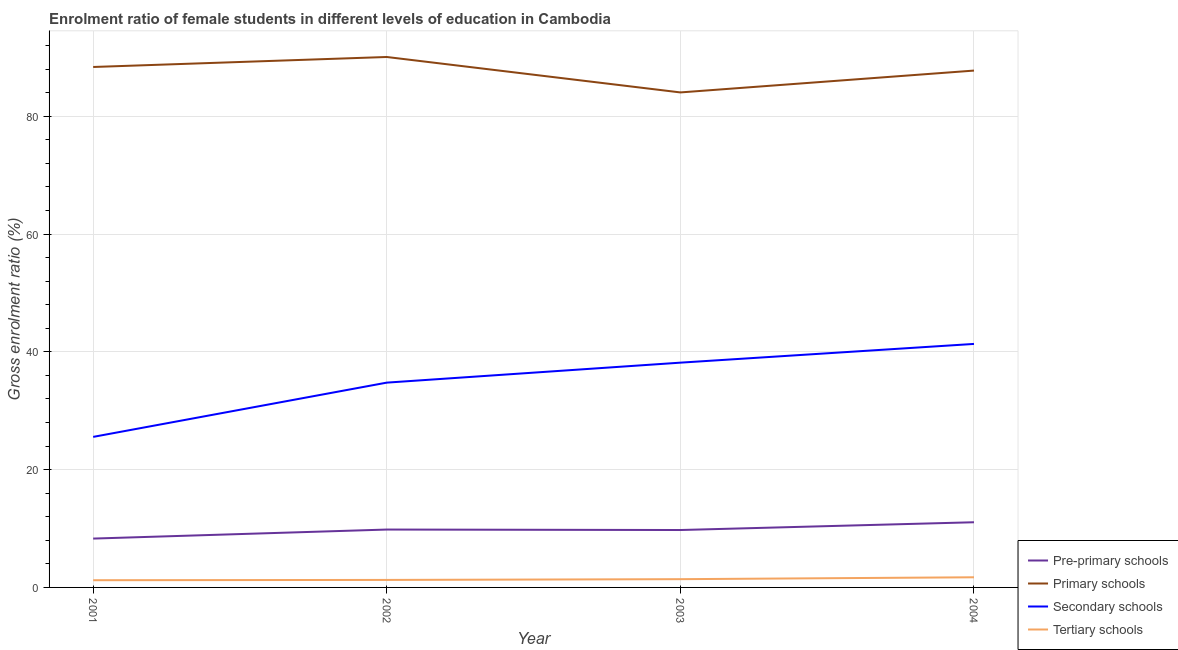How many different coloured lines are there?
Ensure brevity in your answer.  4. Is the number of lines equal to the number of legend labels?
Provide a short and direct response. Yes. What is the gross enrolment ratio(male) in secondary schools in 2004?
Your response must be concise. 41.34. Across all years, what is the maximum gross enrolment ratio(male) in pre-primary schools?
Your answer should be compact. 11.07. Across all years, what is the minimum gross enrolment ratio(male) in secondary schools?
Your response must be concise. 25.56. In which year was the gross enrolment ratio(male) in tertiary schools maximum?
Provide a succinct answer. 2004. In which year was the gross enrolment ratio(male) in primary schools minimum?
Provide a succinct answer. 2003. What is the total gross enrolment ratio(male) in tertiary schools in the graph?
Provide a short and direct response. 5.62. What is the difference between the gross enrolment ratio(male) in tertiary schools in 2002 and that in 2004?
Your response must be concise. -0.45. What is the difference between the gross enrolment ratio(male) in secondary schools in 2004 and the gross enrolment ratio(male) in primary schools in 2001?
Ensure brevity in your answer.  -47.02. What is the average gross enrolment ratio(male) in tertiary schools per year?
Provide a succinct answer. 1.4. In the year 2002, what is the difference between the gross enrolment ratio(male) in tertiary schools and gross enrolment ratio(male) in secondary schools?
Provide a succinct answer. -33.5. In how many years, is the gross enrolment ratio(male) in primary schools greater than 32 %?
Your answer should be very brief. 4. What is the ratio of the gross enrolment ratio(male) in pre-primary schools in 2002 to that in 2004?
Your response must be concise. 0.89. Is the difference between the gross enrolment ratio(male) in pre-primary schools in 2002 and 2003 greater than the difference between the gross enrolment ratio(male) in primary schools in 2002 and 2003?
Your answer should be compact. No. What is the difference between the highest and the second highest gross enrolment ratio(male) in primary schools?
Give a very brief answer. 1.7. What is the difference between the highest and the lowest gross enrolment ratio(male) in secondary schools?
Keep it short and to the point. 15.78. Is the gross enrolment ratio(male) in pre-primary schools strictly greater than the gross enrolment ratio(male) in primary schools over the years?
Make the answer very short. No. Is the gross enrolment ratio(male) in secondary schools strictly less than the gross enrolment ratio(male) in pre-primary schools over the years?
Provide a short and direct response. No. How many lines are there?
Make the answer very short. 4. What is the title of the graph?
Keep it short and to the point. Enrolment ratio of female students in different levels of education in Cambodia. Does "United States" appear as one of the legend labels in the graph?
Offer a terse response. No. What is the Gross enrolment ratio (%) of Pre-primary schools in 2001?
Your response must be concise. 8.29. What is the Gross enrolment ratio (%) of Primary schools in 2001?
Your answer should be very brief. 88.36. What is the Gross enrolment ratio (%) in Secondary schools in 2001?
Offer a terse response. 25.56. What is the Gross enrolment ratio (%) of Tertiary schools in 2001?
Your response must be concise. 1.22. What is the Gross enrolment ratio (%) in Pre-primary schools in 2002?
Keep it short and to the point. 9.83. What is the Gross enrolment ratio (%) in Primary schools in 2002?
Provide a short and direct response. 90.06. What is the Gross enrolment ratio (%) in Secondary schools in 2002?
Offer a very short reply. 34.77. What is the Gross enrolment ratio (%) in Tertiary schools in 2002?
Offer a very short reply. 1.27. What is the Gross enrolment ratio (%) in Pre-primary schools in 2003?
Offer a very short reply. 9.75. What is the Gross enrolment ratio (%) of Primary schools in 2003?
Provide a succinct answer. 84.04. What is the Gross enrolment ratio (%) of Secondary schools in 2003?
Your response must be concise. 38.16. What is the Gross enrolment ratio (%) of Tertiary schools in 2003?
Make the answer very short. 1.4. What is the Gross enrolment ratio (%) of Pre-primary schools in 2004?
Make the answer very short. 11.07. What is the Gross enrolment ratio (%) of Primary schools in 2004?
Provide a succinct answer. 87.75. What is the Gross enrolment ratio (%) of Secondary schools in 2004?
Ensure brevity in your answer.  41.34. What is the Gross enrolment ratio (%) of Tertiary schools in 2004?
Ensure brevity in your answer.  1.72. Across all years, what is the maximum Gross enrolment ratio (%) in Pre-primary schools?
Offer a very short reply. 11.07. Across all years, what is the maximum Gross enrolment ratio (%) of Primary schools?
Provide a short and direct response. 90.06. Across all years, what is the maximum Gross enrolment ratio (%) of Secondary schools?
Offer a very short reply. 41.34. Across all years, what is the maximum Gross enrolment ratio (%) in Tertiary schools?
Your answer should be very brief. 1.72. Across all years, what is the minimum Gross enrolment ratio (%) of Pre-primary schools?
Keep it short and to the point. 8.29. Across all years, what is the minimum Gross enrolment ratio (%) in Primary schools?
Your answer should be very brief. 84.04. Across all years, what is the minimum Gross enrolment ratio (%) of Secondary schools?
Offer a very short reply. 25.56. Across all years, what is the minimum Gross enrolment ratio (%) in Tertiary schools?
Provide a succinct answer. 1.22. What is the total Gross enrolment ratio (%) in Pre-primary schools in the graph?
Offer a terse response. 38.93. What is the total Gross enrolment ratio (%) of Primary schools in the graph?
Keep it short and to the point. 350.22. What is the total Gross enrolment ratio (%) in Secondary schools in the graph?
Keep it short and to the point. 139.84. What is the total Gross enrolment ratio (%) in Tertiary schools in the graph?
Offer a terse response. 5.62. What is the difference between the Gross enrolment ratio (%) in Pre-primary schools in 2001 and that in 2002?
Your answer should be compact. -1.53. What is the difference between the Gross enrolment ratio (%) in Primary schools in 2001 and that in 2002?
Your answer should be compact. -1.7. What is the difference between the Gross enrolment ratio (%) of Secondary schools in 2001 and that in 2002?
Your answer should be very brief. -9.21. What is the difference between the Gross enrolment ratio (%) in Tertiary schools in 2001 and that in 2002?
Ensure brevity in your answer.  -0.05. What is the difference between the Gross enrolment ratio (%) in Pre-primary schools in 2001 and that in 2003?
Offer a very short reply. -1.45. What is the difference between the Gross enrolment ratio (%) in Primary schools in 2001 and that in 2003?
Provide a short and direct response. 4.32. What is the difference between the Gross enrolment ratio (%) in Secondary schools in 2001 and that in 2003?
Make the answer very short. -12.6. What is the difference between the Gross enrolment ratio (%) of Tertiary schools in 2001 and that in 2003?
Give a very brief answer. -0.18. What is the difference between the Gross enrolment ratio (%) of Pre-primary schools in 2001 and that in 2004?
Ensure brevity in your answer.  -2.77. What is the difference between the Gross enrolment ratio (%) in Primary schools in 2001 and that in 2004?
Your response must be concise. 0.61. What is the difference between the Gross enrolment ratio (%) in Secondary schools in 2001 and that in 2004?
Ensure brevity in your answer.  -15.78. What is the difference between the Gross enrolment ratio (%) of Tertiary schools in 2001 and that in 2004?
Make the answer very short. -0.5. What is the difference between the Gross enrolment ratio (%) of Pre-primary schools in 2002 and that in 2003?
Provide a succinct answer. 0.08. What is the difference between the Gross enrolment ratio (%) of Primary schools in 2002 and that in 2003?
Ensure brevity in your answer.  6.02. What is the difference between the Gross enrolment ratio (%) in Secondary schools in 2002 and that in 2003?
Make the answer very short. -3.39. What is the difference between the Gross enrolment ratio (%) in Tertiary schools in 2002 and that in 2003?
Your answer should be very brief. -0.13. What is the difference between the Gross enrolment ratio (%) of Pre-primary schools in 2002 and that in 2004?
Make the answer very short. -1.24. What is the difference between the Gross enrolment ratio (%) of Primary schools in 2002 and that in 2004?
Offer a very short reply. 2.31. What is the difference between the Gross enrolment ratio (%) in Secondary schools in 2002 and that in 2004?
Make the answer very short. -6.57. What is the difference between the Gross enrolment ratio (%) of Tertiary schools in 2002 and that in 2004?
Your answer should be compact. -0.45. What is the difference between the Gross enrolment ratio (%) of Pre-primary schools in 2003 and that in 2004?
Provide a short and direct response. -1.32. What is the difference between the Gross enrolment ratio (%) in Primary schools in 2003 and that in 2004?
Make the answer very short. -3.71. What is the difference between the Gross enrolment ratio (%) of Secondary schools in 2003 and that in 2004?
Keep it short and to the point. -3.18. What is the difference between the Gross enrolment ratio (%) of Tertiary schools in 2003 and that in 2004?
Your response must be concise. -0.32. What is the difference between the Gross enrolment ratio (%) in Pre-primary schools in 2001 and the Gross enrolment ratio (%) in Primary schools in 2002?
Your answer should be very brief. -81.77. What is the difference between the Gross enrolment ratio (%) of Pre-primary schools in 2001 and the Gross enrolment ratio (%) of Secondary schools in 2002?
Give a very brief answer. -26.48. What is the difference between the Gross enrolment ratio (%) of Pre-primary schools in 2001 and the Gross enrolment ratio (%) of Tertiary schools in 2002?
Keep it short and to the point. 7.02. What is the difference between the Gross enrolment ratio (%) of Primary schools in 2001 and the Gross enrolment ratio (%) of Secondary schools in 2002?
Make the answer very short. 53.59. What is the difference between the Gross enrolment ratio (%) of Primary schools in 2001 and the Gross enrolment ratio (%) of Tertiary schools in 2002?
Keep it short and to the point. 87.09. What is the difference between the Gross enrolment ratio (%) in Secondary schools in 2001 and the Gross enrolment ratio (%) in Tertiary schools in 2002?
Give a very brief answer. 24.29. What is the difference between the Gross enrolment ratio (%) in Pre-primary schools in 2001 and the Gross enrolment ratio (%) in Primary schools in 2003?
Your response must be concise. -75.75. What is the difference between the Gross enrolment ratio (%) in Pre-primary schools in 2001 and the Gross enrolment ratio (%) in Secondary schools in 2003?
Provide a short and direct response. -29.87. What is the difference between the Gross enrolment ratio (%) in Pre-primary schools in 2001 and the Gross enrolment ratio (%) in Tertiary schools in 2003?
Provide a short and direct response. 6.89. What is the difference between the Gross enrolment ratio (%) of Primary schools in 2001 and the Gross enrolment ratio (%) of Secondary schools in 2003?
Your answer should be very brief. 50.2. What is the difference between the Gross enrolment ratio (%) of Primary schools in 2001 and the Gross enrolment ratio (%) of Tertiary schools in 2003?
Provide a short and direct response. 86.96. What is the difference between the Gross enrolment ratio (%) in Secondary schools in 2001 and the Gross enrolment ratio (%) in Tertiary schools in 2003?
Offer a very short reply. 24.16. What is the difference between the Gross enrolment ratio (%) in Pre-primary schools in 2001 and the Gross enrolment ratio (%) in Primary schools in 2004?
Ensure brevity in your answer.  -79.46. What is the difference between the Gross enrolment ratio (%) of Pre-primary schools in 2001 and the Gross enrolment ratio (%) of Secondary schools in 2004?
Your answer should be very brief. -33.05. What is the difference between the Gross enrolment ratio (%) of Pre-primary schools in 2001 and the Gross enrolment ratio (%) of Tertiary schools in 2004?
Provide a short and direct response. 6.57. What is the difference between the Gross enrolment ratio (%) of Primary schools in 2001 and the Gross enrolment ratio (%) of Secondary schools in 2004?
Give a very brief answer. 47.02. What is the difference between the Gross enrolment ratio (%) in Primary schools in 2001 and the Gross enrolment ratio (%) in Tertiary schools in 2004?
Keep it short and to the point. 86.64. What is the difference between the Gross enrolment ratio (%) in Secondary schools in 2001 and the Gross enrolment ratio (%) in Tertiary schools in 2004?
Give a very brief answer. 23.84. What is the difference between the Gross enrolment ratio (%) of Pre-primary schools in 2002 and the Gross enrolment ratio (%) of Primary schools in 2003?
Give a very brief answer. -74.22. What is the difference between the Gross enrolment ratio (%) of Pre-primary schools in 2002 and the Gross enrolment ratio (%) of Secondary schools in 2003?
Make the answer very short. -28.34. What is the difference between the Gross enrolment ratio (%) in Pre-primary schools in 2002 and the Gross enrolment ratio (%) in Tertiary schools in 2003?
Ensure brevity in your answer.  8.43. What is the difference between the Gross enrolment ratio (%) in Primary schools in 2002 and the Gross enrolment ratio (%) in Secondary schools in 2003?
Keep it short and to the point. 51.9. What is the difference between the Gross enrolment ratio (%) of Primary schools in 2002 and the Gross enrolment ratio (%) of Tertiary schools in 2003?
Make the answer very short. 88.66. What is the difference between the Gross enrolment ratio (%) of Secondary schools in 2002 and the Gross enrolment ratio (%) of Tertiary schools in 2003?
Ensure brevity in your answer.  33.37. What is the difference between the Gross enrolment ratio (%) in Pre-primary schools in 2002 and the Gross enrolment ratio (%) in Primary schools in 2004?
Your answer should be compact. -77.93. What is the difference between the Gross enrolment ratio (%) in Pre-primary schools in 2002 and the Gross enrolment ratio (%) in Secondary schools in 2004?
Your response must be concise. -31.52. What is the difference between the Gross enrolment ratio (%) of Pre-primary schools in 2002 and the Gross enrolment ratio (%) of Tertiary schools in 2004?
Your answer should be very brief. 8.11. What is the difference between the Gross enrolment ratio (%) of Primary schools in 2002 and the Gross enrolment ratio (%) of Secondary schools in 2004?
Make the answer very short. 48.72. What is the difference between the Gross enrolment ratio (%) in Primary schools in 2002 and the Gross enrolment ratio (%) in Tertiary schools in 2004?
Your answer should be very brief. 88.34. What is the difference between the Gross enrolment ratio (%) of Secondary schools in 2002 and the Gross enrolment ratio (%) of Tertiary schools in 2004?
Your response must be concise. 33.05. What is the difference between the Gross enrolment ratio (%) in Pre-primary schools in 2003 and the Gross enrolment ratio (%) in Primary schools in 2004?
Your answer should be very brief. -78.01. What is the difference between the Gross enrolment ratio (%) of Pre-primary schools in 2003 and the Gross enrolment ratio (%) of Secondary schools in 2004?
Provide a short and direct response. -31.6. What is the difference between the Gross enrolment ratio (%) of Pre-primary schools in 2003 and the Gross enrolment ratio (%) of Tertiary schools in 2004?
Make the answer very short. 8.02. What is the difference between the Gross enrolment ratio (%) of Primary schools in 2003 and the Gross enrolment ratio (%) of Secondary schools in 2004?
Make the answer very short. 42.7. What is the difference between the Gross enrolment ratio (%) of Primary schools in 2003 and the Gross enrolment ratio (%) of Tertiary schools in 2004?
Provide a short and direct response. 82.32. What is the difference between the Gross enrolment ratio (%) in Secondary schools in 2003 and the Gross enrolment ratio (%) in Tertiary schools in 2004?
Your answer should be very brief. 36.44. What is the average Gross enrolment ratio (%) in Pre-primary schools per year?
Give a very brief answer. 9.73. What is the average Gross enrolment ratio (%) of Primary schools per year?
Provide a succinct answer. 87.56. What is the average Gross enrolment ratio (%) in Secondary schools per year?
Provide a succinct answer. 34.96. What is the average Gross enrolment ratio (%) in Tertiary schools per year?
Your answer should be compact. 1.41. In the year 2001, what is the difference between the Gross enrolment ratio (%) in Pre-primary schools and Gross enrolment ratio (%) in Primary schools?
Ensure brevity in your answer.  -80.07. In the year 2001, what is the difference between the Gross enrolment ratio (%) in Pre-primary schools and Gross enrolment ratio (%) in Secondary schools?
Your answer should be compact. -17.27. In the year 2001, what is the difference between the Gross enrolment ratio (%) in Pre-primary schools and Gross enrolment ratio (%) in Tertiary schools?
Your response must be concise. 7.07. In the year 2001, what is the difference between the Gross enrolment ratio (%) of Primary schools and Gross enrolment ratio (%) of Secondary schools?
Your answer should be very brief. 62.8. In the year 2001, what is the difference between the Gross enrolment ratio (%) in Primary schools and Gross enrolment ratio (%) in Tertiary schools?
Your answer should be compact. 87.14. In the year 2001, what is the difference between the Gross enrolment ratio (%) in Secondary schools and Gross enrolment ratio (%) in Tertiary schools?
Keep it short and to the point. 24.34. In the year 2002, what is the difference between the Gross enrolment ratio (%) of Pre-primary schools and Gross enrolment ratio (%) of Primary schools?
Keep it short and to the point. -80.23. In the year 2002, what is the difference between the Gross enrolment ratio (%) of Pre-primary schools and Gross enrolment ratio (%) of Secondary schools?
Provide a succinct answer. -24.94. In the year 2002, what is the difference between the Gross enrolment ratio (%) in Pre-primary schools and Gross enrolment ratio (%) in Tertiary schools?
Your answer should be very brief. 8.55. In the year 2002, what is the difference between the Gross enrolment ratio (%) of Primary schools and Gross enrolment ratio (%) of Secondary schools?
Your answer should be very brief. 55.29. In the year 2002, what is the difference between the Gross enrolment ratio (%) in Primary schools and Gross enrolment ratio (%) in Tertiary schools?
Make the answer very short. 88.79. In the year 2002, what is the difference between the Gross enrolment ratio (%) in Secondary schools and Gross enrolment ratio (%) in Tertiary schools?
Make the answer very short. 33.5. In the year 2003, what is the difference between the Gross enrolment ratio (%) of Pre-primary schools and Gross enrolment ratio (%) of Primary schools?
Your answer should be compact. -74.3. In the year 2003, what is the difference between the Gross enrolment ratio (%) in Pre-primary schools and Gross enrolment ratio (%) in Secondary schools?
Your response must be concise. -28.42. In the year 2003, what is the difference between the Gross enrolment ratio (%) of Pre-primary schools and Gross enrolment ratio (%) of Tertiary schools?
Provide a succinct answer. 8.35. In the year 2003, what is the difference between the Gross enrolment ratio (%) in Primary schools and Gross enrolment ratio (%) in Secondary schools?
Offer a terse response. 45.88. In the year 2003, what is the difference between the Gross enrolment ratio (%) of Primary schools and Gross enrolment ratio (%) of Tertiary schools?
Keep it short and to the point. 82.64. In the year 2003, what is the difference between the Gross enrolment ratio (%) of Secondary schools and Gross enrolment ratio (%) of Tertiary schools?
Your answer should be compact. 36.76. In the year 2004, what is the difference between the Gross enrolment ratio (%) of Pre-primary schools and Gross enrolment ratio (%) of Primary schools?
Ensure brevity in your answer.  -76.69. In the year 2004, what is the difference between the Gross enrolment ratio (%) of Pre-primary schools and Gross enrolment ratio (%) of Secondary schools?
Provide a succinct answer. -30.28. In the year 2004, what is the difference between the Gross enrolment ratio (%) in Pre-primary schools and Gross enrolment ratio (%) in Tertiary schools?
Provide a succinct answer. 9.34. In the year 2004, what is the difference between the Gross enrolment ratio (%) of Primary schools and Gross enrolment ratio (%) of Secondary schools?
Offer a terse response. 46.41. In the year 2004, what is the difference between the Gross enrolment ratio (%) in Primary schools and Gross enrolment ratio (%) in Tertiary schools?
Offer a terse response. 86.03. In the year 2004, what is the difference between the Gross enrolment ratio (%) of Secondary schools and Gross enrolment ratio (%) of Tertiary schools?
Offer a very short reply. 39.62. What is the ratio of the Gross enrolment ratio (%) in Pre-primary schools in 2001 to that in 2002?
Provide a short and direct response. 0.84. What is the ratio of the Gross enrolment ratio (%) of Primary schools in 2001 to that in 2002?
Provide a short and direct response. 0.98. What is the ratio of the Gross enrolment ratio (%) of Secondary schools in 2001 to that in 2002?
Ensure brevity in your answer.  0.74. What is the ratio of the Gross enrolment ratio (%) of Tertiary schools in 2001 to that in 2002?
Your answer should be compact. 0.96. What is the ratio of the Gross enrolment ratio (%) in Pre-primary schools in 2001 to that in 2003?
Make the answer very short. 0.85. What is the ratio of the Gross enrolment ratio (%) in Primary schools in 2001 to that in 2003?
Make the answer very short. 1.05. What is the ratio of the Gross enrolment ratio (%) in Secondary schools in 2001 to that in 2003?
Offer a very short reply. 0.67. What is the ratio of the Gross enrolment ratio (%) of Tertiary schools in 2001 to that in 2003?
Your response must be concise. 0.87. What is the ratio of the Gross enrolment ratio (%) of Pre-primary schools in 2001 to that in 2004?
Ensure brevity in your answer.  0.75. What is the ratio of the Gross enrolment ratio (%) in Secondary schools in 2001 to that in 2004?
Offer a very short reply. 0.62. What is the ratio of the Gross enrolment ratio (%) in Tertiary schools in 2001 to that in 2004?
Give a very brief answer. 0.71. What is the ratio of the Gross enrolment ratio (%) in Pre-primary schools in 2002 to that in 2003?
Your answer should be compact. 1.01. What is the ratio of the Gross enrolment ratio (%) in Primary schools in 2002 to that in 2003?
Ensure brevity in your answer.  1.07. What is the ratio of the Gross enrolment ratio (%) of Secondary schools in 2002 to that in 2003?
Offer a very short reply. 0.91. What is the ratio of the Gross enrolment ratio (%) in Tertiary schools in 2002 to that in 2003?
Your answer should be compact. 0.91. What is the ratio of the Gross enrolment ratio (%) in Pre-primary schools in 2002 to that in 2004?
Provide a short and direct response. 0.89. What is the ratio of the Gross enrolment ratio (%) in Primary schools in 2002 to that in 2004?
Give a very brief answer. 1.03. What is the ratio of the Gross enrolment ratio (%) in Secondary schools in 2002 to that in 2004?
Your response must be concise. 0.84. What is the ratio of the Gross enrolment ratio (%) in Tertiary schools in 2002 to that in 2004?
Give a very brief answer. 0.74. What is the ratio of the Gross enrolment ratio (%) of Pre-primary schools in 2003 to that in 2004?
Ensure brevity in your answer.  0.88. What is the ratio of the Gross enrolment ratio (%) in Primary schools in 2003 to that in 2004?
Offer a terse response. 0.96. What is the ratio of the Gross enrolment ratio (%) of Secondary schools in 2003 to that in 2004?
Your response must be concise. 0.92. What is the ratio of the Gross enrolment ratio (%) of Tertiary schools in 2003 to that in 2004?
Your response must be concise. 0.81. What is the difference between the highest and the second highest Gross enrolment ratio (%) in Pre-primary schools?
Your answer should be compact. 1.24. What is the difference between the highest and the second highest Gross enrolment ratio (%) in Primary schools?
Make the answer very short. 1.7. What is the difference between the highest and the second highest Gross enrolment ratio (%) in Secondary schools?
Your answer should be compact. 3.18. What is the difference between the highest and the second highest Gross enrolment ratio (%) in Tertiary schools?
Offer a terse response. 0.32. What is the difference between the highest and the lowest Gross enrolment ratio (%) in Pre-primary schools?
Provide a succinct answer. 2.77. What is the difference between the highest and the lowest Gross enrolment ratio (%) in Primary schools?
Provide a short and direct response. 6.02. What is the difference between the highest and the lowest Gross enrolment ratio (%) in Secondary schools?
Offer a terse response. 15.78. What is the difference between the highest and the lowest Gross enrolment ratio (%) in Tertiary schools?
Provide a short and direct response. 0.5. 